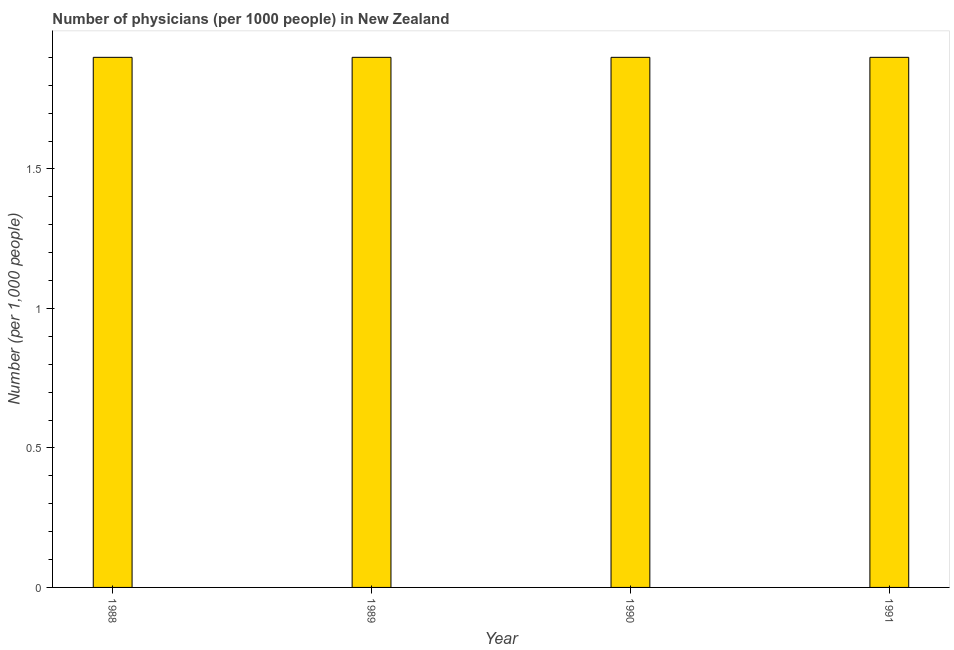Does the graph contain grids?
Your answer should be compact. No. What is the title of the graph?
Offer a very short reply. Number of physicians (per 1000 people) in New Zealand. What is the label or title of the Y-axis?
Offer a very short reply. Number (per 1,0 people). Across all years, what is the maximum number of physicians?
Offer a terse response. 1.9. In which year was the number of physicians maximum?
Make the answer very short. 1988. What is the sum of the number of physicians?
Your answer should be very brief. 7.6. What is the median number of physicians?
Provide a short and direct response. 1.9. In how many years, is the number of physicians greater than 0.5 ?
Your answer should be very brief. 4. Do a majority of the years between 1990 and 1988 (inclusive) have number of physicians greater than 1.5 ?
Make the answer very short. Yes. What is the ratio of the number of physicians in 1988 to that in 1991?
Your response must be concise. 1. Is the number of physicians in 1988 less than that in 1989?
Provide a succinct answer. No. What is the difference between the highest and the second highest number of physicians?
Give a very brief answer. 0. In how many years, is the number of physicians greater than the average number of physicians taken over all years?
Ensure brevity in your answer.  0. How many years are there in the graph?
Your response must be concise. 4. What is the difference between two consecutive major ticks on the Y-axis?
Provide a succinct answer. 0.5. Are the values on the major ticks of Y-axis written in scientific E-notation?
Your answer should be compact. No. What is the Number (per 1,000 people) of 1989?
Offer a very short reply. 1.9. What is the Number (per 1,000 people) in 1991?
Provide a succinct answer. 1.9. What is the difference between the Number (per 1,000 people) in 1988 and 1990?
Give a very brief answer. 0. What is the ratio of the Number (per 1,000 people) in 1988 to that in 1989?
Your answer should be very brief. 1. What is the ratio of the Number (per 1,000 people) in 1988 to that in 1991?
Offer a very short reply. 1. What is the ratio of the Number (per 1,000 people) in 1989 to that in 1991?
Make the answer very short. 1. What is the ratio of the Number (per 1,000 people) in 1990 to that in 1991?
Your answer should be very brief. 1. 